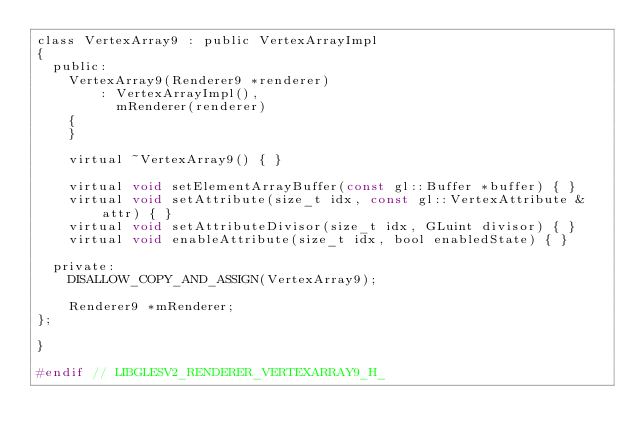<code> <loc_0><loc_0><loc_500><loc_500><_C_>class VertexArray9 : public VertexArrayImpl
{
  public:
    VertexArray9(Renderer9 *renderer)
        : VertexArrayImpl(),
          mRenderer(renderer)
    {
    }

    virtual ~VertexArray9() { }

    virtual void setElementArrayBuffer(const gl::Buffer *buffer) { }
    virtual void setAttribute(size_t idx, const gl::VertexAttribute &attr) { }
    virtual void setAttributeDivisor(size_t idx, GLuint divisor) { }
    virtual void enableAttribute(size_t idx, bool enabledState) { }

  private:
    DISALLOW_COPY_AND_ASSIGN(VertexArray9);

    Renderer9 *mRenderer;
};

}

#endif // LIBGLESV2_RENDERER_VERTEXARRAY9_H_
</code> 